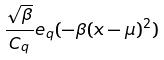Convert formula to latex. <formula><loc_0><loc_0><loc_500><loc_500>\frac { \sqrt { \beta } } { C _ { q } } e _ { q } ( - \beta ( x - \mu ) ^ { 2 } )</formula> 